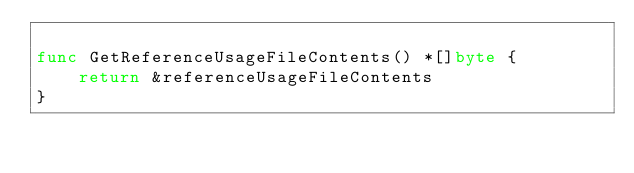Convert code to text. <code><loc_0><loc_0><loc_500><loc_500><_Go_>
func GetReferenceUsageFileContents() *[]byte {
	return &referenceUsageFileContents
}
</code> 